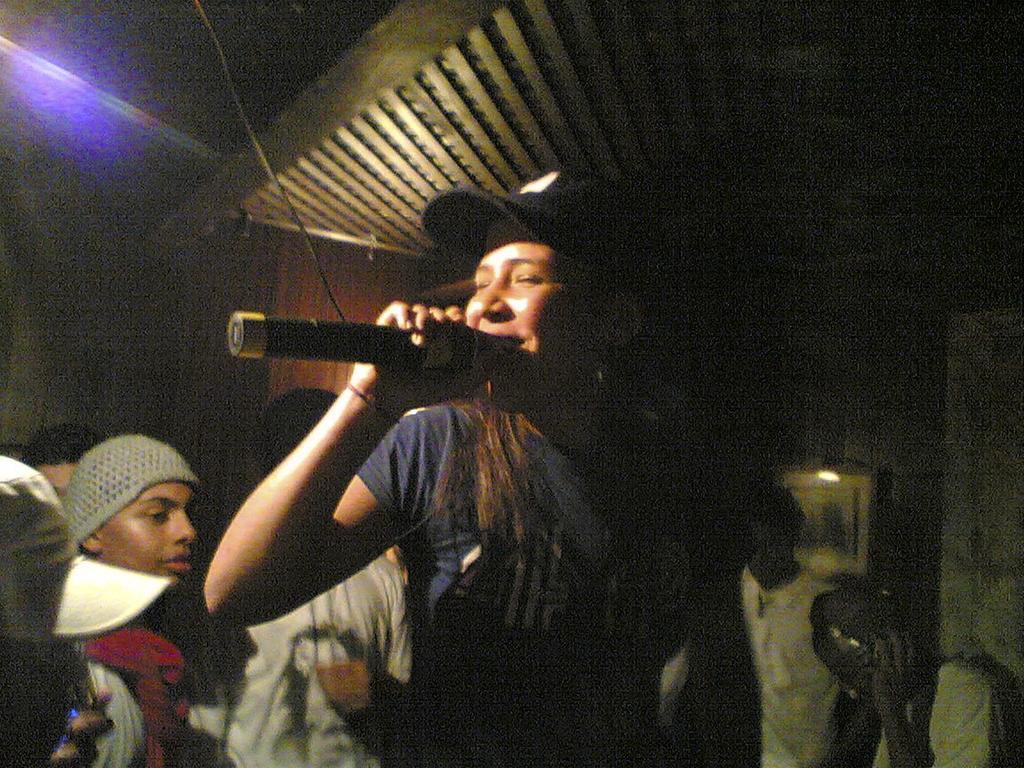How would you summarize this image in a sentence or two? Here is a woman blue color T-shirt and cap. She is holding mike and singing. At background I can see few people standing. This looks like a photo frame attached to the wall. At the top this looks like a wooden rooftop. 